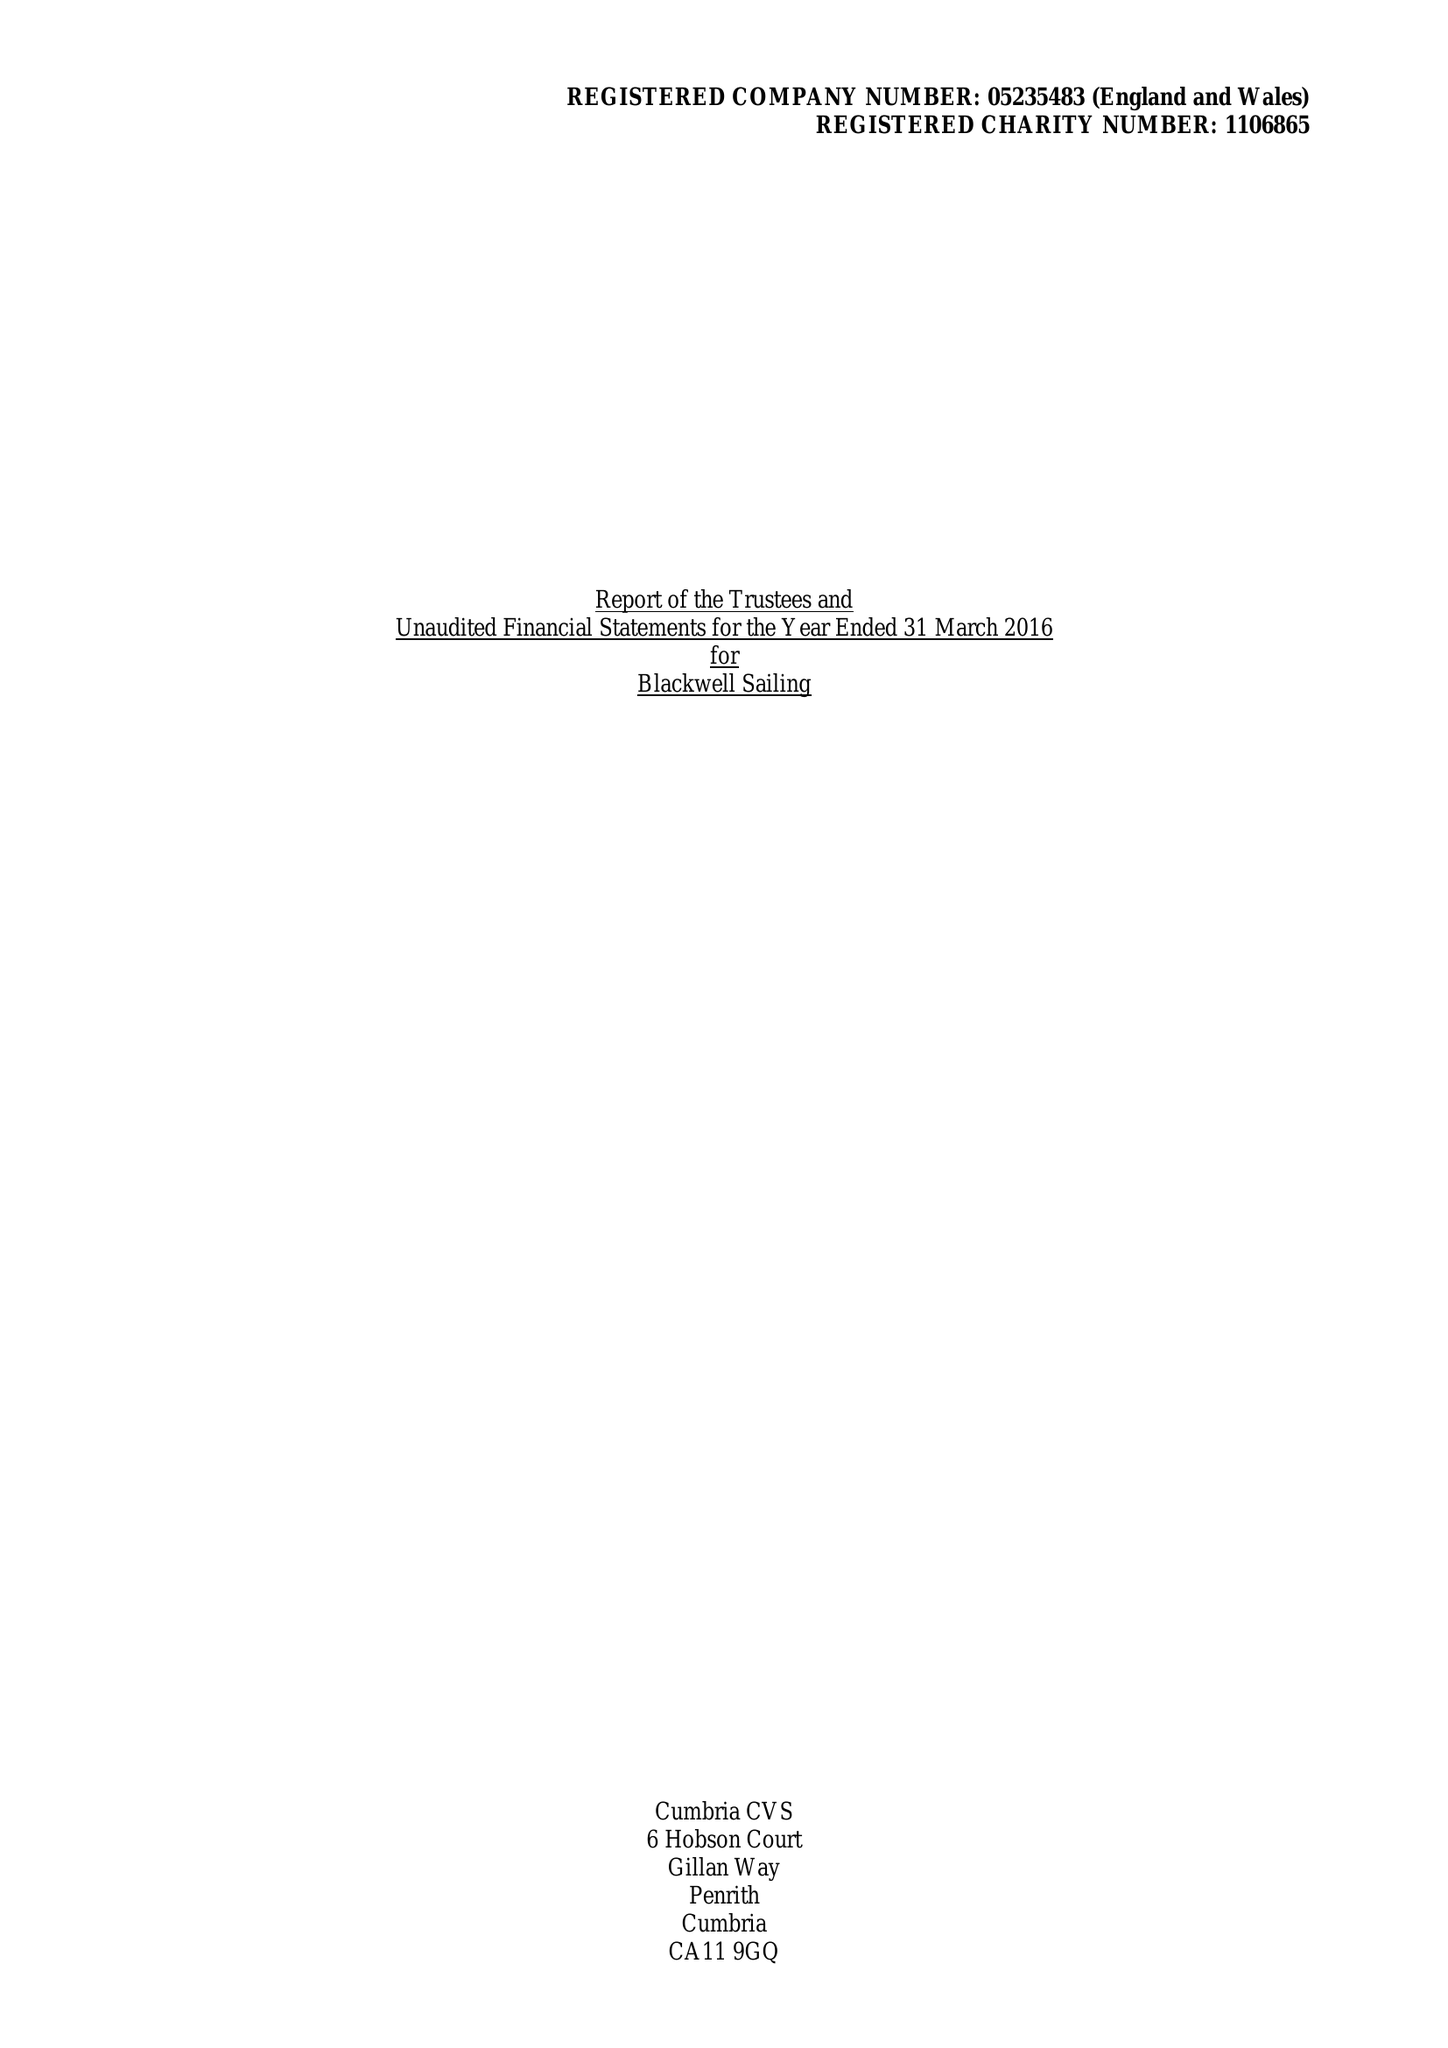What is the value for the income_annually_in_british_pounds?
Answer the question using a single word or phrase. 66172.00 